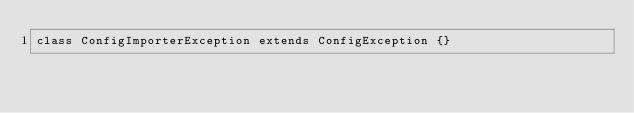<code> <loc_0><loc_0><loc_500><loc_500><_PHP_>class ConfigImporterException extends ConfigException {}
</code> 